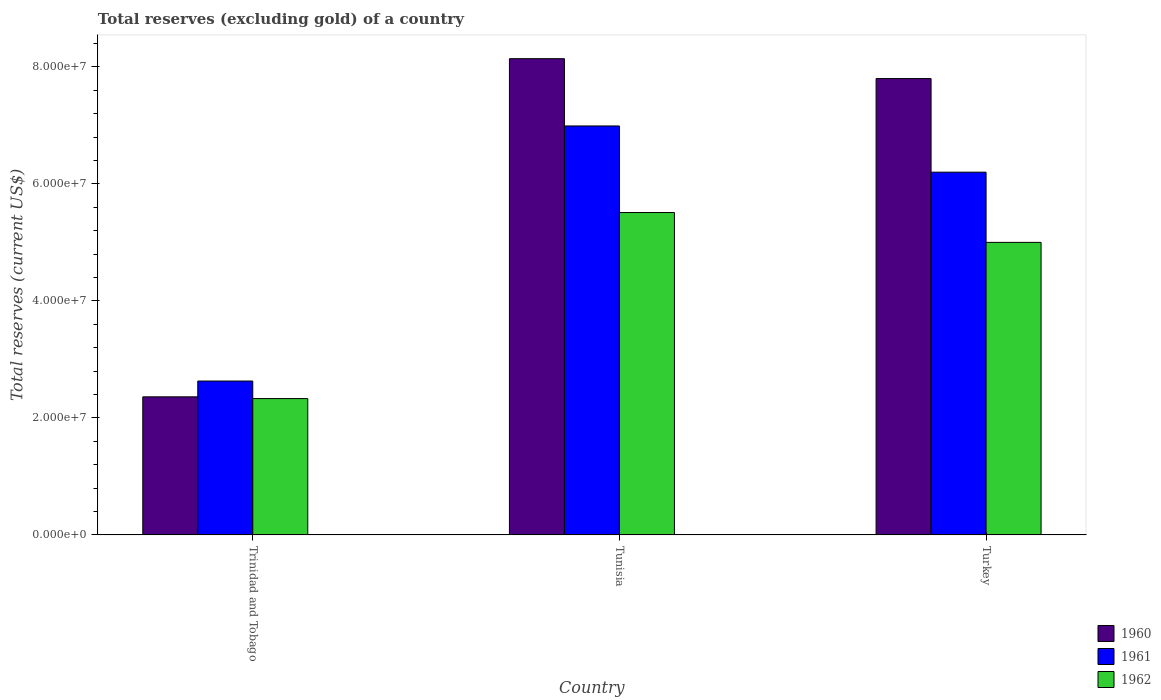How many different coloured bars are there?
Keep it short and to the point. 3. Are the number of bars on each tick of the X-axis equal?
Offer a terse response. Yes. How many bars are there on the 3rd tick from the right?
Offer a very short reply. 3. What is the label of the 2nd group of bars from the left?
Provide a short and direct response. Tunisia. In how many cases, is the number of bars for a given country not equal to the number of legend labels?
Your answer should be compact. 0. What is the total reserves (excluding gold) in 1962 in Tunisia?
Keep it short and to the point. 5.51e+07. Across all countries, what is the maximum total reserves (excluding gold) in 1962?
Your answer should be compact. 5.51e+07. Across all countries, what is the minimum total reserves (excluding gold) in 1961?
Give a very brief answer. 2.63e+07. In which country was the total reserves (excluding gold) in 1961 maximum?
Your response must be concise. Tunisia. In which country was the total reserves (excluding gold) in 1962 minimum?
Ensure brevity in your answer.  Trinidad and Tobago. What is the total total reserves (excluding gold) in 1960 in the graph?
Make the answer very short. 1.83e+08. What is the difference between the total reserves (excluding gold) in 1962 in Tunisia and that in Turkey?
Your answer should be compact. 5.10e+06. What is the difference between the total reserves (excluding gold) in 1962 in Tunisia and the total reserves (excluding gold) in 1960 in Trinidad and Tobago?
Make the answer very short. 3.15e+07. What is the average total reserves (excluding gold) in 1960 per country?
Ensure brevity in your answer.  6.10e+07. What is the difference between the total reserves (excluding gold) of/in 1960 and total reserves (excluding gold) of/in 1962 in Turkey?
Your answer should be very brief. 2.80e+07. In how many countries, is the total reserves (excluding gold) in 1960 greater than 20000000 US$?
Give a very brief answer. 3. What is the ratio of the total reserves (excluding gold) in 1960 in Tunisia to that in Turkey?
Keep it short and to the point. 1.04. Is the total reserves (excluding gold) in 1962 in Trinidad and Tobago less than that in Turkey?
Offer a very short reply. Yes. Is the difference between the total reserves (excluding gold) in 1960 in Tunisia and Turkey greater than the difference between the total reserves (excluding gold) in 1962 in Tunisia and Turkey?
Give a very brief answer. No. What is the difference between the highest and the second highest total reserves (excluding gold) in 1962?
Keep it short and to the point. 5.10e+06. What is the difference between the highest and the lowest total reserves (excluding gold) in 1962?
Provide a short and direct response. 3.18e+07. Is the sum of the total reserves (excluding gold) in 1962 in Tunisia and Turkey greater than the maximum total reserves (excluding gold) in 1961 across all countries?
Your response must be concise. Yes. What does the 3rd bar from the left in Turkey represents?
Your answer should be compact. 1962. What does the 1st bar from the right in Turkey represents?
Provide a short and direct response. 1962. Are all the bars in the graph horizontal?
Your response must be concise. No. How many countries are there in the graph?
Your answer should be very brief. 3. Are the values on the major ticks of Y-axis written in scientific E-notation?
Make the answer very short. Yes. Does the graph contain any zero values?
Your answer should be very brief. No. Does the graph contain grids?
Your answer should be compact. No. Where does the legend appear in the graph?
Ensure brevity in your answer.  Bottom right. How many legend labels are there?
Provide a succinct answer. 3. How are the legend labels stacked?
Provide a short and direct response. Vertical. What is the title of the graph?
Give a very brief answer. Total reserves (excluding gold) of a country. Does "2001" appear as one of the legend labels in the graph?
Offer a very short reply. No. What is the label or title of the Y-axis?
Give a very brief answer. Total reserves (current US$). What is the Total reserves (current US$) of 1960 in Trinidad and Tobago?
Your answer should be very brief. 2.36e+07. What is the Total reserves (current US$) of 1961 in Trinidad and Tobago?
Offer a terse response. 2.63e+07. What is the Total reserves (current US$) in 1962 in Trinidad and Tobago?
Your answer should be compact. 2.33e+07. What is the Total reserves (current US$) in 1960 in Tunisia?
Your answer should be compact. 8.14e+07. What is the Total reserves (current US$) in 1961 in Tunisia?
Ensure brevity in your answer.  6.99e+07. What is the Total reserves (current US$) in 1962 in Tunisia?
Give a very brief answer. 5.51e+07. What is the Total reserves (current US$) of 1960 in Turkey?
Your response must be concise. 7.80e+07. What is the Total reserves (current US$) of 1961 in Turkey?
Make the answer very short. 6.20e+07. What is the Total reserves (current US$) in 1962 in Turkey?
Give a very brief answer. 5.00e+07. Across all countries, what is the maximum Total reserves (current US$) in 1960?
Your answer should be compact. 8.14e+07. Across all countries, what is the maximum Total reserves (current US$) in 1961?
Keep it short and to the point. 6.99e+07. Across all countries, what is the maximum Total reserves (current US$) in 1962?
Ensure brevity in your answer.  5.51e+07. Across all countries, what is the minimum Total reserves (current US$) of 1960?
Give a very brief answer. 2.36e+07. Across all countries, what is the minimum Total reserves (current US$) in 1961?
Offer a very short reply. 2.63e+07. Across all countries, what is the minimum Total reserves (current US$) in 1962?
Offer a terse response. 2.33e+07. What is the total Total reserves (current US$) of 1960 in the graph?
Keep it short and to the point. 1.83e+08. What is the total Total reserves (current US$) of 1961 in the graph?
Offer a terse response. 1.58e+08. What is the total Total reserves (current US$) of 1962 in the graph?
Give a very brief answer. 1.28e+08. What is the difference between the Total reserves (current US$) of 1960 in Trinidad and Tobago and that in Tunisia?
Your answer should be very brief. -5.78e+07. What is the difference between the Total reserves (current US$) in 1961 in Trinidad and Tobago and that in Tunisia?
Your response must be concise. -4.36e+07. What is the difference between the Total reserves (current US$) in 1962 in Trinidad and Tobago and that in Tunisia?
Provide a succinct answer. -3.18e+07. What is the difference between the Total reserves (current US$) of 1960 in Trinidad and Tobago and that in Turkey?
Provide a succinct answer. -5.44e+07. What is the difference between the Total reserves (current US$) in 1961 in Trinidad and Tobago and that in Turkey?
Your response must be concise. -3.57e+07. What is the difference between the Total reserves (current US$) in 1962 in Trinidad and Tobago and that in Turkey?
Your answer should be compact. -2.67e+07. What is the difference between the Total reserves (current US$) in 1960 in Tunisia and that in Turkey?
Your response must be concise. 3.40e+06. What is the difference between the Total reserves (current US$) of 1961 in Tunisia and that in Turkey?
Your response must be concise. 7.90e+06. What is the difference between the Total reserves (current US$) in 1962 in Tunisia and that in Turkey?
Offer a terse response. 5.10e+06. What is the difference between the Total reserves (current US$) of 1960 in Trinidad and Tobago and the Total reserves (current US$) of 1961 in Tunisia?
Provide a short and direct response. -4.63e+07. What is the difference between the Total reserves (current US$) of 1960 in Trinidad and Tobago and the Total reserves (current US$) of 1962 in Tunisia?
Provide a short and direct response. -3.15e+07. What is the difference between the Total reserves (current US$) of 1961 in Trinidad and Tobago and the Total reserves (current US$) of 1962 in Tunisia?
Offer a very short reply. -2.88e+07. What is the difference between the Total reserves (current US$) of 1960 in Trinidad and Tobago and the Total reserves (current US$) of 1961 in Turkey?
Provide a short and direct response. -3.84e+07. What is the difference between the Total reserves (current US$) of 1960 in Trinidad and Tobago and the Total reserves (current US$) of 1962 in Turkey?
Provide a short and direct response. -2.64e+07. What is the difference between the Total reserves (current US$) in 1961 in Trinidad and Tobago and the Total reserves (current US$) in 1962 in Turkey?
Keep it short and to the point. -2.37e+07. What is the difference between the Total reserves (current US$) of 1960 in Tunisia and the Total reserves (current US$) of 1961 in Turkey?
Provide a succinct answer. 1.94e+07. What is the difference between the Total reserves (current US$) in 1960 in Tunisia and the Total reserves (current US$) in 1962 in Turkey?
Offer a very short reply. 3.14e+07. What is the difference between the Total reserves (current US$) of 1961 in Tunisia and the Total reserves (current US$) of 1962 in Turkey?
Make the answer very short. 1.99e+07. What is the average Total reserves (current US$) of 1960 per country?
Offer a very short reply. 6.10e+07. What is the average Total reserves (current US$) of 1961 per country?
Your response must be concise. 5.27e+07. What is the average Total reserves (current US$) in 1962 per country?
Offer a terse response. 4.28e+07. What is the difference between the Total reserves (current US$) of 1960 and Total reserves (current US$) of 1961 in Trinidad and Tobago?
Ensure brevity in your answer.  -2.70e+06. What is the difference between the Total reserves (current US$) in 1960 and Total reserves (current US$) in 1962 in Trinidad and Tobago?
Provide a succinct answer. 3.00e+05. What is the difference between the Total reserves (current US$) of 1961 and Total reserves (current US$) of 1962 in Trinidad and Tobago?
Offer a very short reply. 3.00e+06. What is the difference between the Total reserves (current US$) in 1960 and Total reserves (current US$) in 1961 in Tunisia?
Ensure brevity in your answer.  1.15e+07. What is the difference between the Total reserves (current US$) in 1960 and Total reserves (current US$) in 1962 in Tunisia?
Provide a short and direct response. 2.63e+07. What is the difference between the Total reserves (current US$) in 1961 and Total reserves (current US$) in 1962 in Tunisia?
Your answer should be compact. 1.48e+07. What is the difference between the Total reserves (current US$) of 1960 and Total reserves (current US$) of 1961 in Turkey?
Provide a short and direct response. 1.60e+07. What is the difference between the Total reserves (current US$) of 1960 and Total reserves (current US$) of 1962 in Turkey?
Make the answer very short. 2.80e+07. What is the ratio of the Total reserves (current US$) of 1960 in Trinidad and Tobago to that in Tunisia?
Offer a very short reply. 0.29. What is the ratio of the Total reserves (current US$) in 1961 in Trinidad and Tobago to that in Tunisia?
Your answer should be very brief. 0.38. What is the ratio of the Total reserves (current US$) of 1962 in Trinidad and Tobago to that in Tunisia?
Offer a very short reply. 0.42. What is the ratio of the Total reserves (current US$) in 1960 in Trinidad and Tobago to that in Turkey?
Make the answer very short. 0.3. What is the ratio of the Total reserves (current US$) in 1961 in Trinidad and Tobago to that in Turkey?
Your answer should be compact. 0.42. What is the ratio of the Total reserves (current US$) of 1962 in Trinidad and Tobago to that in Turkey?
Make the answer very short. 0.47. What is the ratio of the Total reserves (current US$) of 1960 in Tunisia to that in Turkey?
Your answer should be very brief. 1.04. What is the ratio of the Total reserves (current US$) in 1961 in Tunisia to that in Turkey?
Offer a very short reply. 1.13. What is the ratio of the Total reserves (current US$) of 1962 in Tunisia to that in Turkey?
Your answer should be very brief. 1.1. What is the difference between the highest and the second highest Total reserves (current US$) of 1960?
Provide a succinct answer. 3.40e+06. What is the difference between the highest and the second highest Total reserves (current US$) of 1961?
Your answer should be very brief. 7.90e+06. What is the difference between the highest and the second highest Total reserves (current US$) of 1962?
Keep it short and to the point. 5.10e+06. What is the difference between the highest and the lowest Total reserves (current US$) in 1960?
Keep it short and to the point. 5.78e+07. What is the difference between the highest and the lowest Total reserves (current US$) of 1961?
Your response must be concise. 4.36e+07. What is the difference between the highest and the lowest Total reserves (current US$) of 1962?
Provide a succinct answer. 3.18e+07. 